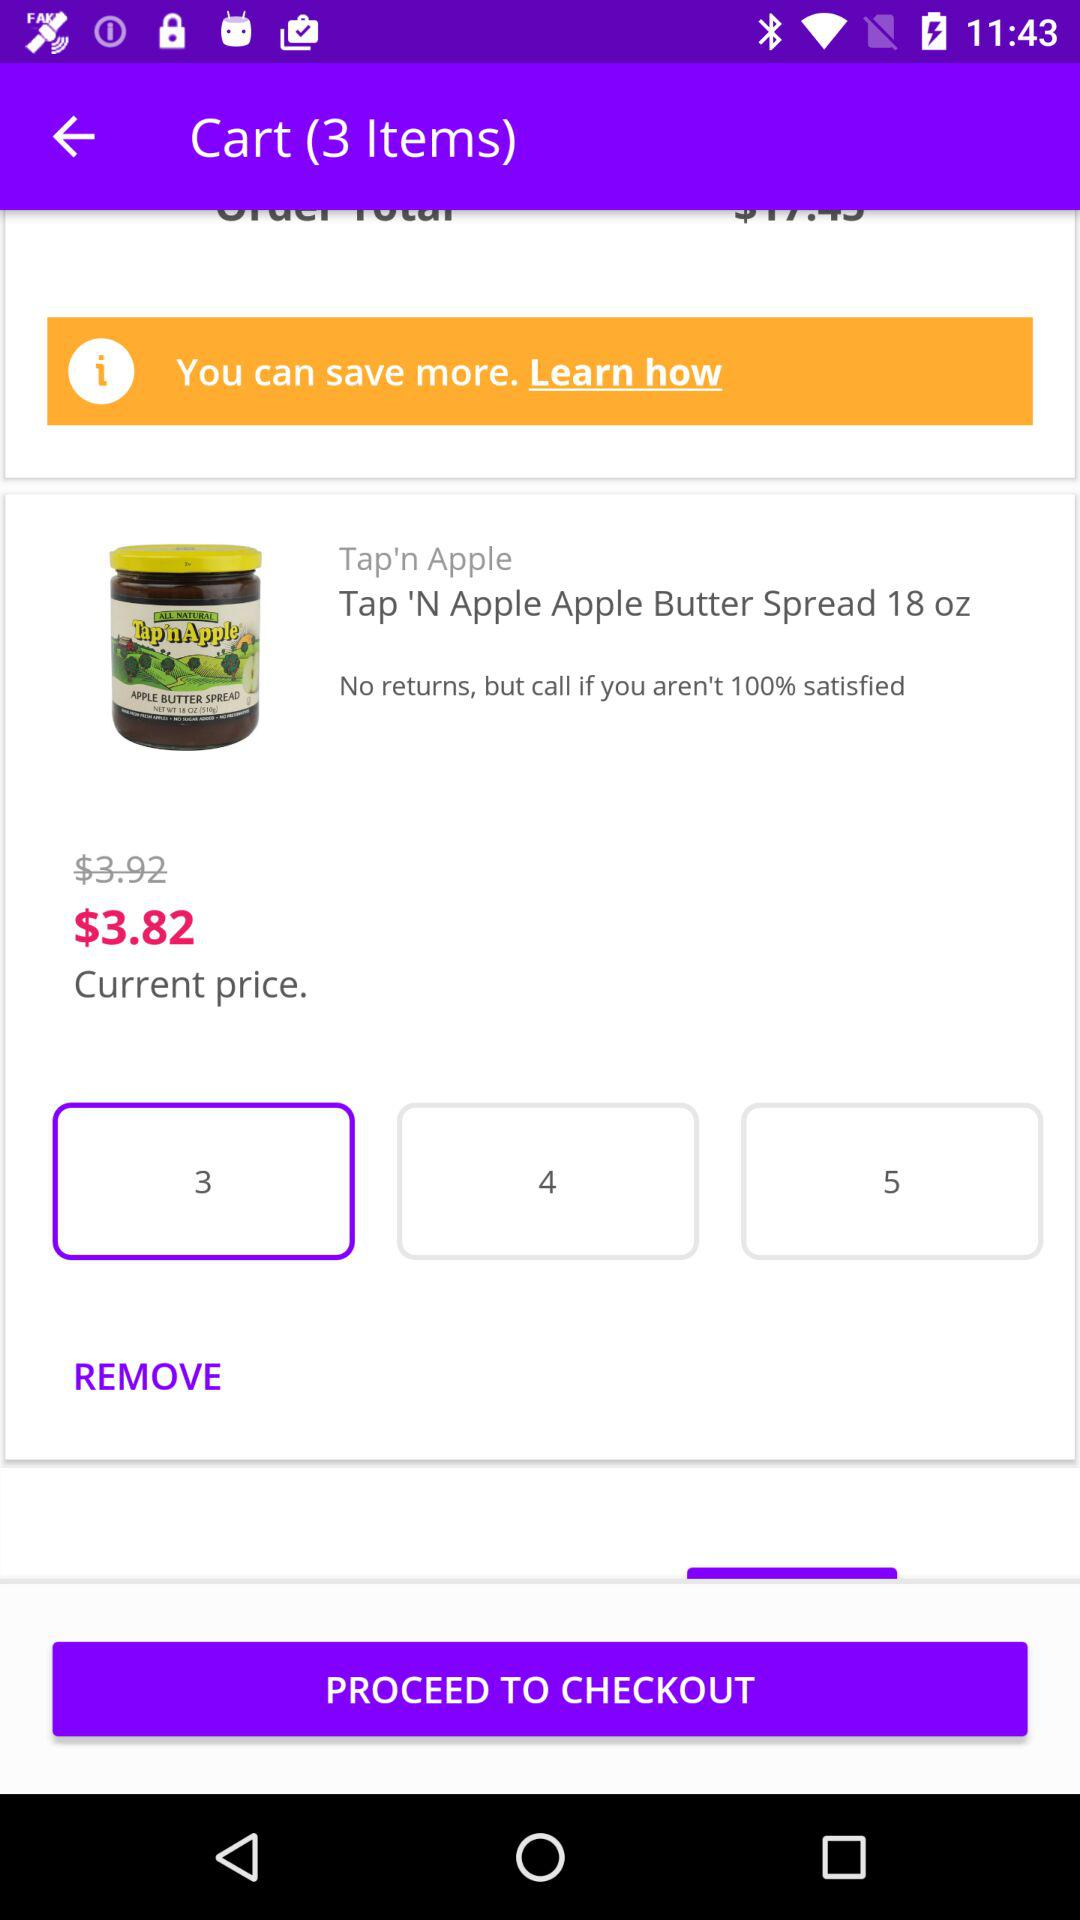What is the original price of the item? The original price of the item is $3.92. 